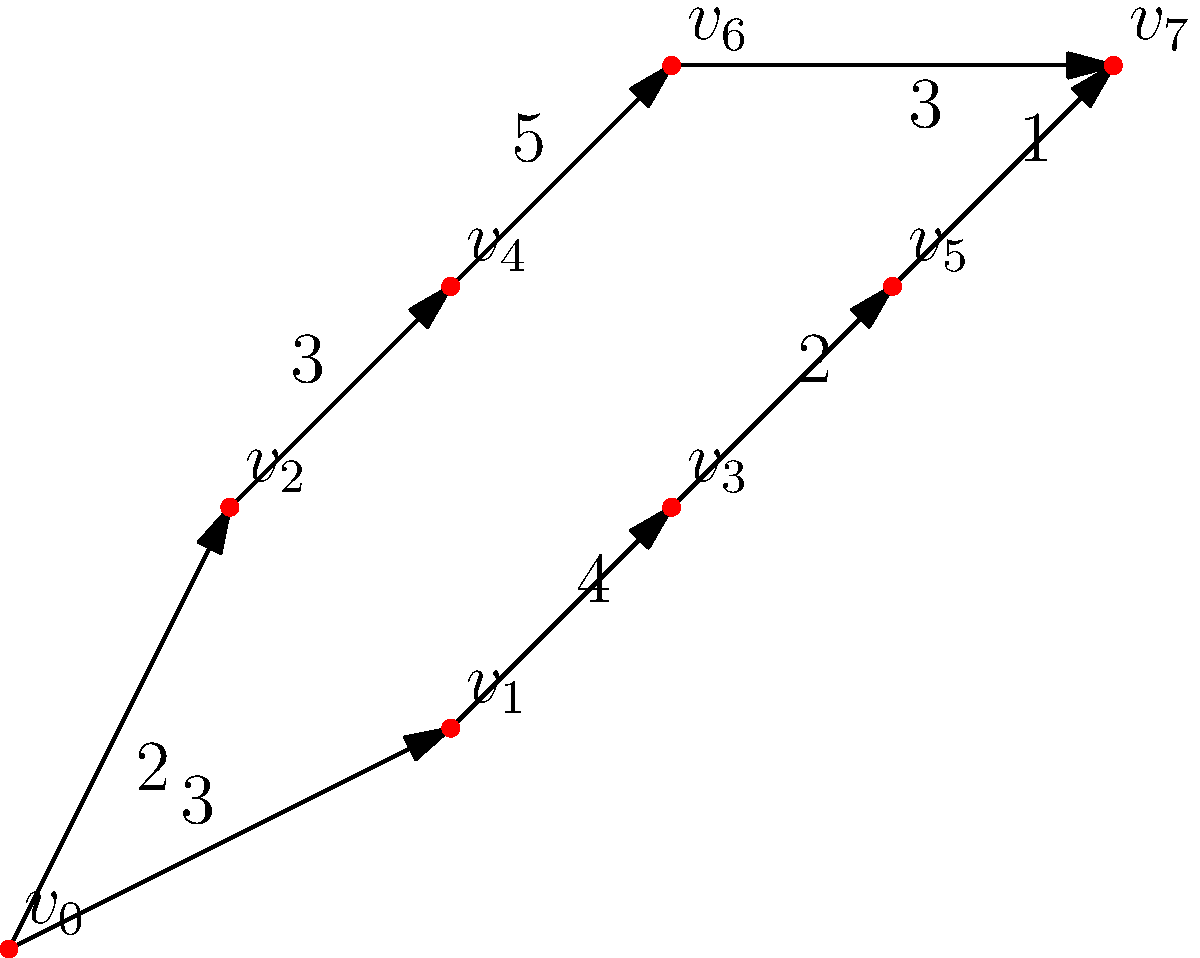As a soccer player, you need to find the optimal path from the starting position ($v_0$) to the goal ($v_7$) on the field. The weighted graph represents different routes you can take, where the weights indicate the difficulty or time required to move between positions. What is the shortest path from $v_0$ to $v_7$, and what is its total weight? To find the shortest path from $v_0$ to $v_7$, we'll use Dijkstra's algorithm:

1. Initialize distances: $d(v_0) = 0$, all others $\infty$
2. Set $v_0$ as the current vertex
3. For each neighbor of the current vertex:
   - Calculate tentative distance
   - Update if smaller than current known distance
4. Mark current vertex as visited
5. Select unvisited vertex with smallest known distance as new current vertex
6. Repeat steps 3-5 until $v_7$ is reached

Applying the algorithm:

1. From $v_0$:
   - $d(v_1) = 3$
   - $d(v_2) = 2$
2. Select $v_2$ (smaller distance)
3. From $v_2$:
   - $d(v_4) = 2 + 3 = 5$
4. Select $v_1$
5. From $v_1$:
   - $d(v_3) = 3 + 4 = 7$
6. Select $v_4$
7. From $v_4$:
   - $d(v_6) = 5 + 5 = 10$
8. Select $v_3$
9. From $v_3$:
   - $d(v_5) = 7 + 2 = 9$
10. Select $v_5$
11. From $v_5$:
    - $d(v_7) = 9 + 1 = 10$

The shortest path is $v_0 \rightarrow v_1 \rightarrow v_3 \rightarrow v_5 \rightarrow v_7$ with a total weight of 10.
Answer: $v_0 \rightarrow v_1 \rightarrow v_3 \rightarrow v_5 \rightarrow v_7$; total weight: 10 